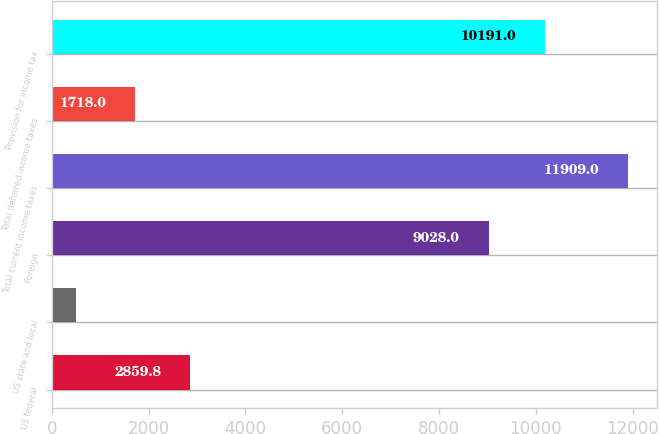Convert chart. <chart><loc_0><loc_0><loc_500><loc_500><bar_chart><fcel>US federal<fcel>US state and local<fcel>Foreign<fcel>Total current income taxes<fcel>Total deferred income taxes<fcel>Provision for income tax<nl><fcel>2859.8<fcel>491<fcel>9028<fcel>11909<fcel>1718<fcel>10191<nl></chart> 